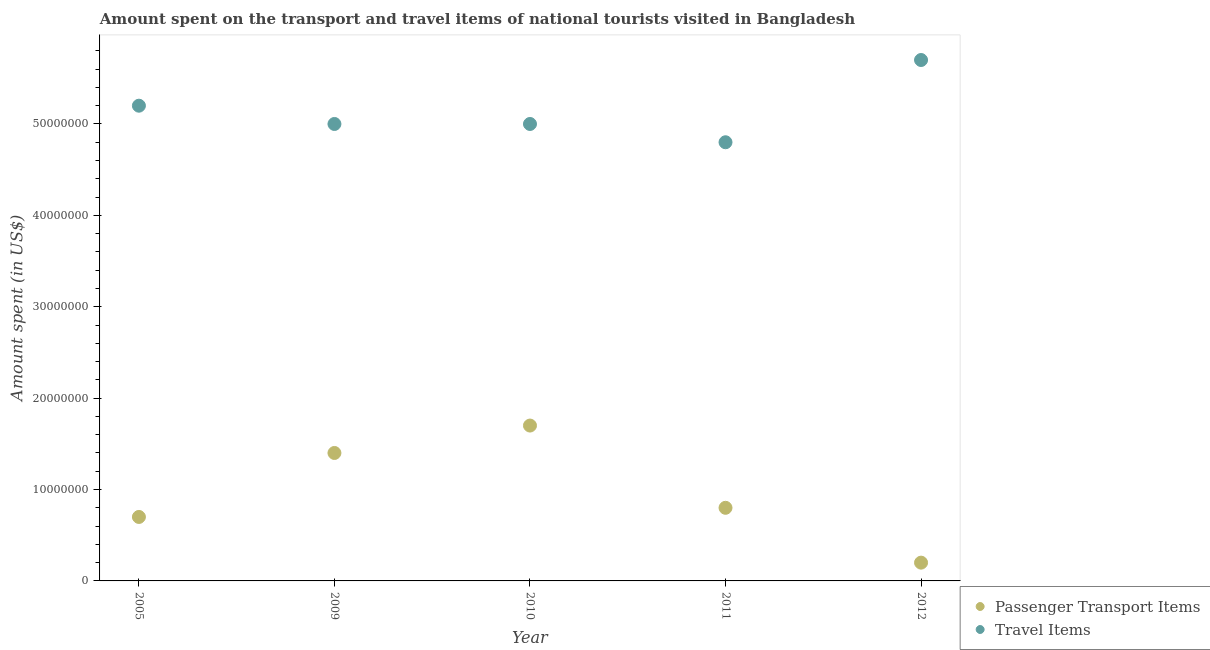What is the amount spent on passenger transport items in 2011?
Offer a very short reply. 8.00e+06. Across all years, what is the maximum amount spent on passenger transport items?
Offer a terse response. 1.70e+07. Across all years, what is the minimum amount spent in travel items?
Keep it short and to the point. 4.80e+07. In which year was the amount spent in travel items maximum?
Make the answer very short. 2012. In which year was the amount spent on passenger transport items minimum?
Offer a very short reply. 2012. What is the total amount spent in travel items in the graph?
Your response must be concise. 2.57e+08. What is the difference between the amount spent in travel items in 2010 and that in 2012?
Make the answer very short. -7.00e+06. What is the difference between the amount spent in travel items in 2012 and the amount spent on passenger transport items in 2005?
Offer a terse response. 5.00e+07. What is the average amount spent on passenger transport items per year?
Your answer should be very brief. 9.60e+06. In the year 2012, what is the difference between the amount spent in travel items and amount spent on passenger transport items?
Your answer should be very brief. 5.50e+07. In how many years, is the amount spent in travel items greater than 56000000 US$?
Your answer should be compact. 1. What is the ratio of the amount spent in travel items in 2005 to that in 2009?
Ensure brevity in your answer.  1.04. What is the difference between the highest and the second highest amount spent on passenger transport items?
Provide a succinct answer. 3.00e+06. What is the difference between the highest and the lowest amount spent on passenger transport items?
Offer a terse response. 1.50e+07. Is the sum of the amount spent on passenger transport items in 2010 and 2012 greater than the maximum amount spent in travel items across all years?
Provide a short and direct response. No. Does the amount spent on passenger transport items monotonically increase over the years?
Provide a short and direct response. No. Is the amount spent on passenger transport items strictly less than the amount spent in travel items over the years?
Your response must be concise. Yes. How many years are there in the graph?
Your response must be concise. 5. What is the difference between two consecutive major ticks on the Y-axis?
Offer a terse response. 1.00e+07. Are the values on the major ticks of Y-axis written in scientific E-notation?
Offer a very short reply. No. Where does the legend appear in the graph?
Your response must be concise. Bottom right. What is the title of the graph?
Provide a short and direct response. Amount spent on the transport and travel items of national tourists visited in Bangladesh. What is the label or title of the X-axis?
Your response must be concise. Year. What is the label or title of the Y-axis?
Provide a succinct answer. Amount spent (in US$). What is the Amount spent (in US$) of Passenger Transport Items in 2005?
Give a very brief answer. 7.00e+06. What is the Amount spent (in US$) in Travel Items in 2005?
Make the answer very short. 5.20e+07. What is the Amount spent (in US$) of Passenger Transport Items in 2009?
Provide a short and direct response. 1.40e+07. What is the Amount spent (in US$) of Passenger Transport Items in 2010?
Your answer should be compact. 1.70e+07. What is the Amount spent (in US$) of Travel Items in 2010?
Offer a terse response. 5.00e+07. What is the Amount spent (in US$) of Passenger Transport Items in 2011?
Your answer should be compact. 8.00e+06. What is the Amount spent (in US$) in Travel Items in 2011?
Make the answer very short. 4.80e+07. What is the Amount spent (in US$) in Passenger Transport Items in 2012?
Offer a very short reply. 2.00e+06. What is the Amount spent (in US$) in Travel Items in 2012?
Your answer should be compact. 5.70e+07. Across all years, what is the maximum Amount spent (in US$) of Passenger Transport Items?
Give a very brief answer. 1.70e+07. Across all years, what is the maximum Amount spent (in US$) of Travel Items?
Provide a succinct answer. 5.70e+07. Across all years, what is the minimum Amount spent (in US$) in Travel Items?
Keep it short and to the point. 4.80e+07. What is the total Amount spent (in US$) in Passenger Transport Items in the graph?
Make the answer very short. 4.80e+07. What is the total Amount spent (in US$) in Travel Items in the graph?
Your answer should be very brief. 2.57e+08. What is the difference between the Amount spent (in US$) in Passenger Transport Items in 2005 and that in 2009?
Ensure brevity in your answer.  -7.00e+06. What is the difference between the Amount spent (in US$) of Travel Items in 2005 and that in 2009?
Your response must be concise. 2.00e+06. What is the difference between the Amount spent (in US$) in Passenger Transport Items in 2005 and that in 2010?
Give a very brief answer. -1.00e+07. What is the difference between the Amount spent (in US$) of Travel Items in 2005 and that in 2011?
Provide a succinct answer. 4.00e+06. What is the difference between the Amount spent (in US$) of Travel Items in 2005 and that in 2012?
Your response must be concise. -5.00e+06. What is the difference between the Amount spent (in US$) of Passenger Transport Items in 2009 and that in 2010?
Keep it short and to the point. -3.00e+06. What is the difference between the Amount spent (in US$) in Passenger Transport Items in 2009 and that in 2011?
Make the answer very short. 6.00e+06. What is the difference between the Amount spent (in US$) in Travel Items in 2009 and that in 2011?
Offer a terse response. 2.00e+06. What is the difference between the Amount spent (in US$) in Passenger Transport Items in 2009 and that in 2012?
Offer a very short reply. 1.20e+07. What is the difference between the Amount spent (in US$) in Travel Items in 2009 and that in 2012?
Offer a very short reply. -7.00e+06. What is the difference between the Amount spent (in US$) in Passenger Transport Items in 2010 and that in 2011?
Offer a very short reply. 9.00e+06. What is the difference between the Amount spent (in US$) of Passenger Transport Items in 2010 and that in 2012?
Your answer should be compact. 1.50e+07. What is the difference between the Amount spent (in US$) in Travel Items in 2010 and that in 2012?
Provide a short and direct response. -7.00e+06. What is the difference between the Amount spent (in US$) in Passenger Transport Items in 2011 and that in 2012?
Make the answer very short. 6.00e+06. What is the difference between the Amount spent (in US$) of Travel Items in 2011 and that in 2012?
Offer a terse response. -9.00e+06. What is the difference between the Amount spent (in US$) of Passenger Transport Items in 2005 and the Amount spent (in US$) of Travel Items in 2009?
Make the answer very short. -4.30e+07. What is the difference between the Amount spent (in US$) in Passenger Transport Items in 2005 and the Amount spent (in US$) in Travel Items in 2010?
Provide a short and direct response. -4.30e+07. What is the difference between the Amount spent (in US$) of Passenger Transport Items in 2005 and the Amount spent (in US$) of Travel Items in 2011?
Your answer should be very brief. -4.10e+07. What is the difference between the Amount spent (in US$) in Passenger Transport Items in 2005 and the Amount spent (in US$) in Travel Items in 2012?
Ensure brevity in your answer.  -5.00e+07. What is the difference between the Amount spent (in US$) in Passenger Transport Items in 2009 and the Amount spent (in US$) in Travel Items in 2010?
Ensure brevity in your answer.  -3.60e+07. What is the difference between the Amount spent (in US$) in Passenger Transport Items in 2009 and the Amount spent (in US$) in Travel Items in 2011?
Ensure brevity in your answer.  -3.40e+07. What is the difference between the Amount spent (in US$) of Passenger Transport Items in 2009 and the Amount spent (in US$) of Travel Items in 2012?
Your answer should be very brief. -4.30e+07. What is the difference between the Amount spent (in US$) of Passenger Transport Items in 2010 and the Amount spent (in US$) of Travel Items in 2011?
Offer a terse response. -3.10e+07. What is the difference between the Amount spent (in US$) of Passenger Transport Items in 2010 and the Amount spent (in US$) of Travel Items in 2012?
Offer a terse response. -4.00e+07. What is the difference between the Amount spent (in US$) in Passenger Transport Items in 2011 and the Amount spent (in US$) in Travel Items in 2012?
Your answer should be very brief. -4.90e+07. What is the average Amount spent (in US$) in Passenger Transport Items per year?
Give a very brief answer. 9.60e+06. What is the average Amount spent (in US$) of Travel Items per year?
Your answer should be compact. 5.14e+07. In the year 2005, what is the difference between the Amount spent (in US$) in Passenger Transport Items and Amount spent (in US$) in Travel Items?
Your answer should be very brief. -4.50e+07. In the year 2009, what is the difference between the Amount spent (in US$) of Passenger Transport Items and Amount spent (in US$) of Travel Items?
Provide a short and direct response. -3.60e+07. In the year 2010, what is the difference between the Amount spent (in US$) of Passenger Transport Items and Amount spent (in US$) of Travel Items?
Offer a terse response. -3.30e+07. In the year 2011, what is the difference between the Amount spent (in US$) in Passenger Transport Items and Amount spent (in US$) in Travel Items?
Your response must be concise. -4.00e+07. In the year 2012, what is the difference between the Amount spent (in US$) in Passenger Transport Items and Amount spent (in US$) in Travel Items?
Provide a short and direct response. -5.50e+07. What is the ratio of the Amount spent (in US$) of Travel Items in 2005 to that in 2009?
Offer a terse response. 1.04. What is the ratio of the Amount spent (in US$) of Passenger Transport Items in 2005 to that in 2010?
Your response must be concise. 0.41. What is the ratio of the Amount spent (in US$) of Travel Items in 2005 to that in 2011?
Provide a succinct answer. 1.08. What is the ratio of the Amount spent (in US$) in Travel Items in 2005 to that in 2012?
Your answer should be very brief. 0.91. What is the ratio of the Amount spent (in US$) of Passenger Transport Items in 2009 to that in 2010?
Your response must be concise. 0.82. What is the ratio of the Amount spent (in US$) of Travel Items in 2009 to that in 2011?
Give a very brief answer. 1.04. What is the ratio of the Amount spent (in US$) in Passenger Transport Items in 2009 to that in 2012?
Provide a short and direct response. 7. What is the ratio of the Amount spent (in US$) of Travel Items in 2009 to that in 2012?
Provide a short and direct response. 0.88. What is the ratio of the Amount spent (in US$) of Passenger Transport Items in 2010 to that in 2011?
Give a very brief answer. 2.12. What is the ratio of the Amount spent (in US$) of Travel Items in 2010 to that in 2011?
Provide a short and direct response. 1.04. What is the ratio of the Amount spent (in US$) in Passenger Transport Items in 2010 to that in 2012?
Provide a succinct answer. 8.5. What is the ratio of the Amount spent (in US$) of Travel Items in 2010 to that in 2012?
Your response must be concise. 0.88. What is the ratio of the Amount spent (in US$) of Passenger Transport Items in 2011 to that in 2012?
Ensure brevity in your answer.  4. What is the ratio of the Amount spent (in US$) in Travel Items in 2011 to that in 2012?
Offer a very short reply. 0.84. What is the difference between the highest and the second highest Amount spent (in US$) of Passenger Transport Items?
Give a very brief answer. 3.00e+06. What is the difference between the highest and the second highest Amount spent (in US$) in Travel Items?
Offer a terse response. 5.00e+06. What is the difference between the highest and the lowest Amount spent (in US$) in Passenger Transport Items?
Ensure brevity in your answer.  1.50e+07. What is the difference between the highest and the lowest Amount spent (in US$) of Travel Items?
Provide a succinct answer. 9.00e+06. 